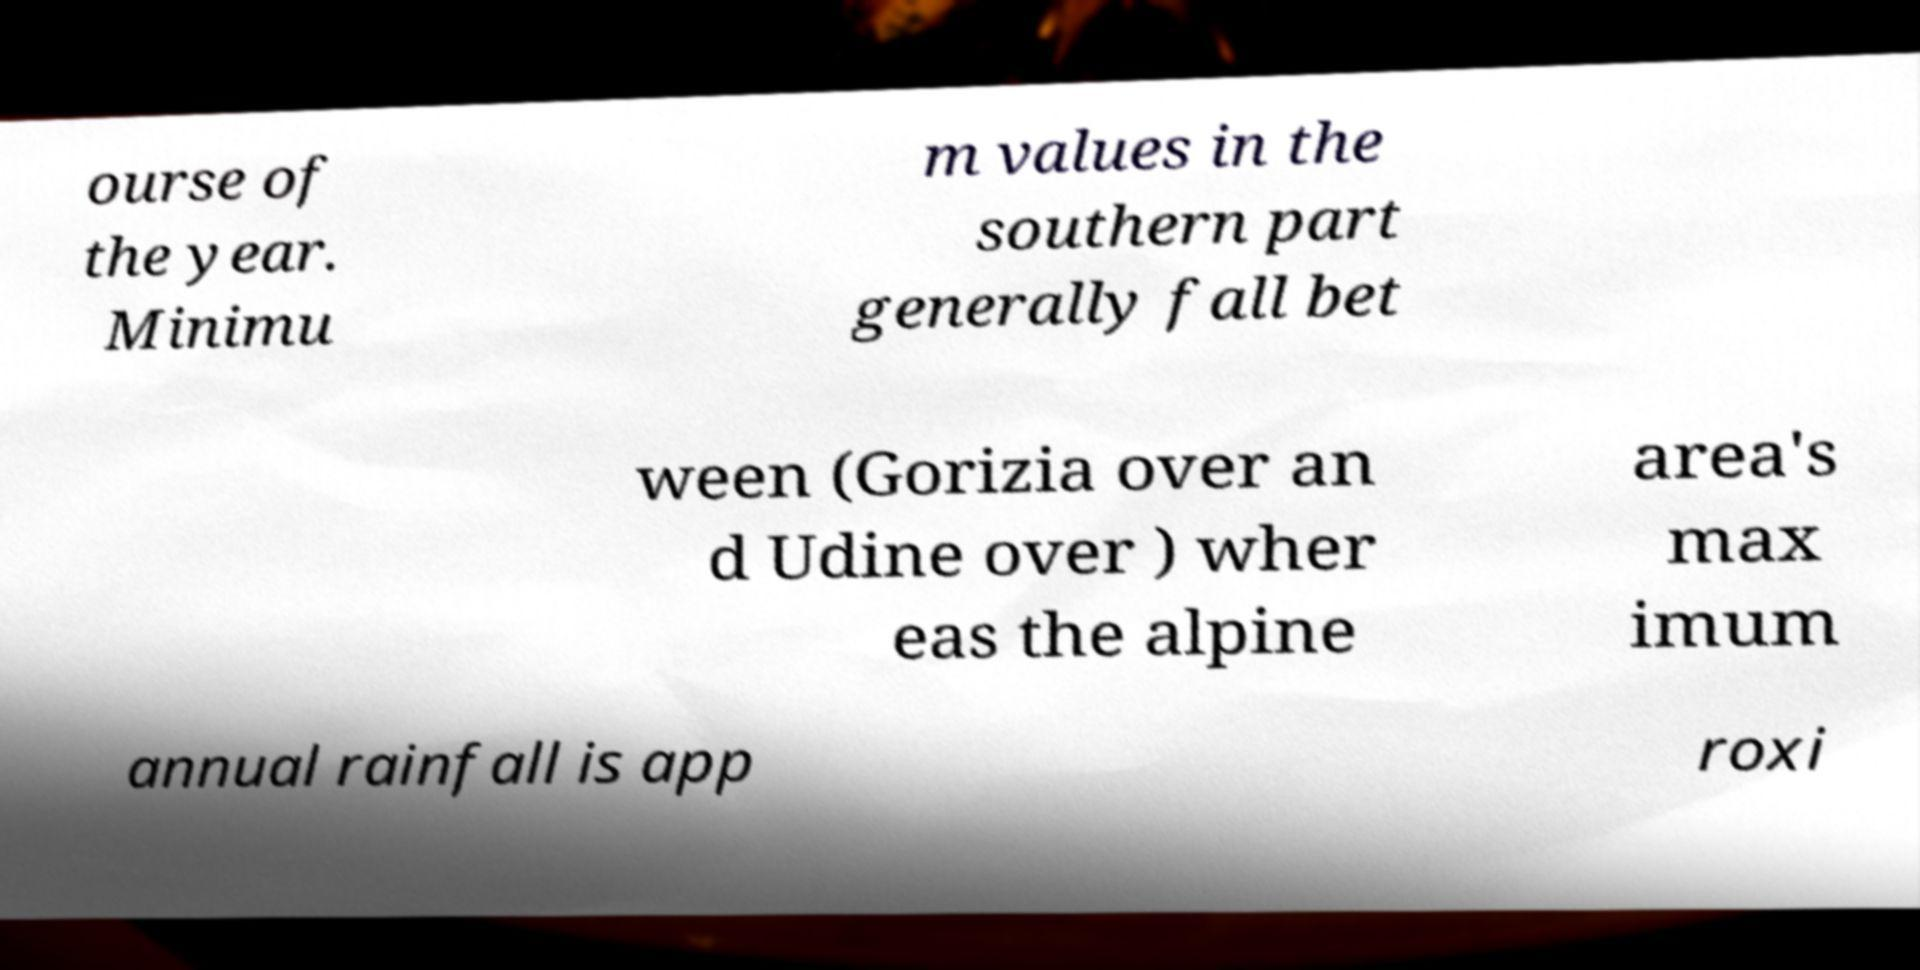Please read and relay the text visible in this image. What does it say? ourse of the year. Minimu m values in the southern part generally fall bet ween (Gorizia over an d Udine over ) wher eas the alpine area's max imum annual rainfall is app roxi 